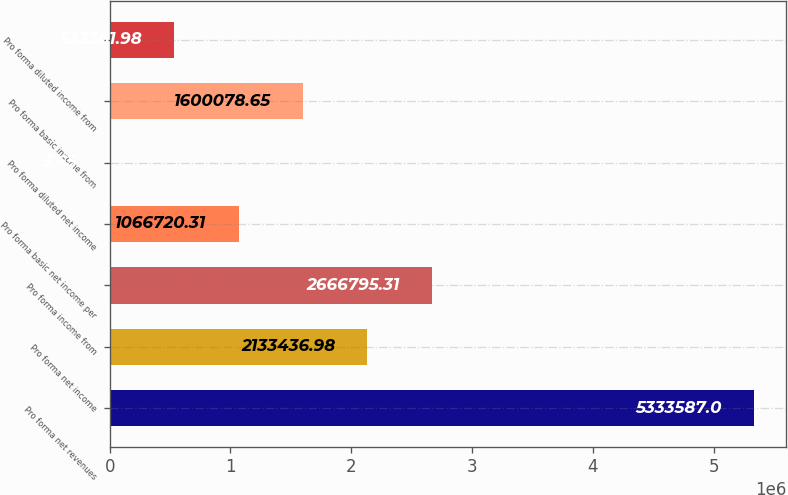<chart> <loc_0><loc_0><loc_500><loc_500><bar_chart><fcel>Pro forma net revenues<fcel>Pro forma net income<fcel>Pro forma income from<fcel>Pro forma basic net income per<fcel>Pro forma diluted net income<fcel>Pro forma basic income from<fcel>Pro forma diluted income from<nl><fcel>5.33359e+06<fcel>2.13344e+06<fcel>2.6668e+06<fcel>1.06672e+06<fcel>3.65<fcel>1.60008e+06<fcel>533362<nl></chart> 